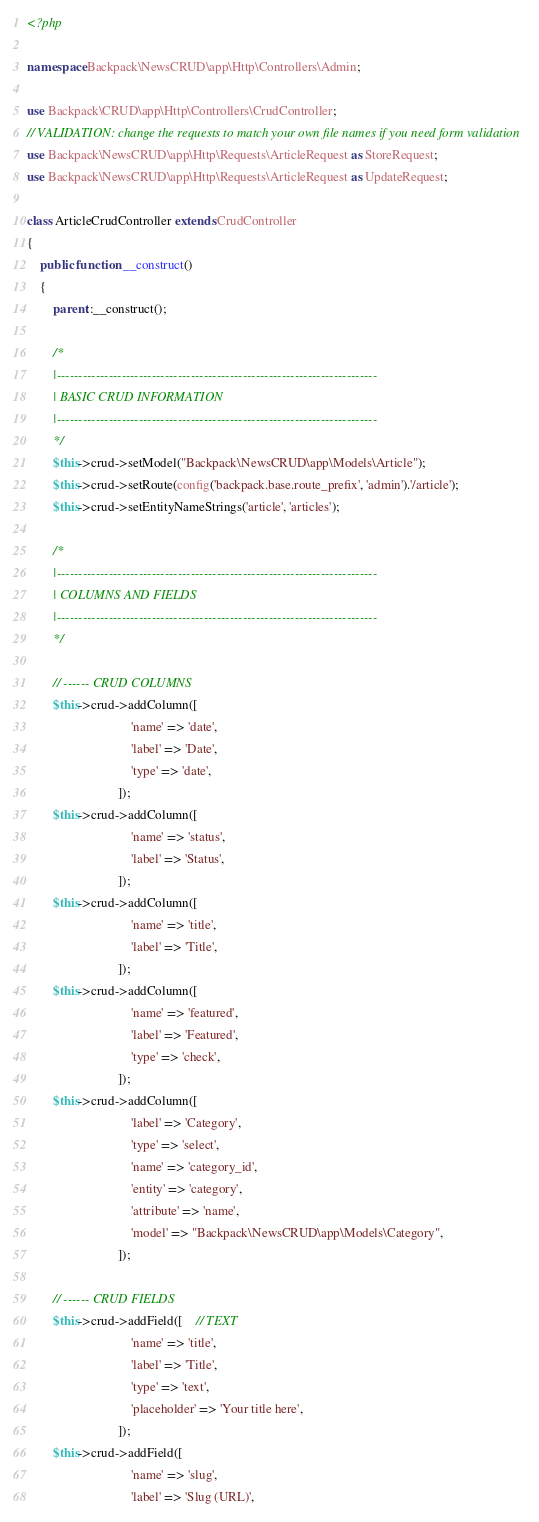Convert code to text. <code><loc_0><loc_0><loc_500><loc_500><_PHP_><?php

namespace Backpack\NewsCRUD\app\Http\Controllers\Admin;

use Backpack\CRUD\app\Http\Controllers\CrudController;
// VALIDATION: change the requests to match your own file names if you need form validation
use Backpack\NewsCRUD\app\Http\Requests\ArticleRequest as StoreRequest;
use Backpack\NewsCRUD\app\Http\Requests\ArticleRequest as UpdateRequest;

class ArticleCrudController extends CrudController
{
    public function __construct()
    {
        parent::__construct();

        /*
        |--------------------------------------------------------------------------
        | BASIC CRUD INFORMATION
        |--------------------------------------------------------------------------
        */
        $this->crud->setModel("Backpack\NewsCRUD\app\Models\Article");
        $this->crud->setRoute(config('backpack.base.route_prefix', 'admin').'/article');
        $this->crud->setEntityNameStrings('article', 'articles');

        /*
        |--------------------------------------------------------------------------
        | COLUMNS AND FIELDS
        |--------------------------------------------------------------------------
        */

        // ------ CRUD COLUMNS
        $this->crud->addColumn([
                                'name' => 'date',
                                'label' => 'Date',
                                'type' => 'date',
                            ]);
        $this->crud->addColumn([
                                'name' => 'status',
                                'label' => 'Status',
                            ]);
        $this->crud->addColumn([
                                'name' => 'title',
                                'label' => 'Title',
                            ]);
        $this->crud->addColumn([
                                'name' => 'featured',
                                'label' => 'Featured',
                                'type' => 'check',
                            ]);
        $this->crud->addColumn([
                                'label' => 'Category',
                                'type' => 'select',
                                'name' => 'category_id',
                                'entity' => 'category',
                                'attribute' => 'name',
                                'model' => "Backpack\NewsCRUD\app\Models\Category",
                            ]);

        // ------ CRUD FIELDS
        $this->crud->addField([    // TEXT
                                'name' => 'title',
                                'label' => 'Title',
                                'type' => 'text',
                                'placeholder' => 'Your title here',
                            ]);
        $this->crud->addField([
                                'name' => 'slug',
                                'label' => 'Slug (URL)',</code> 